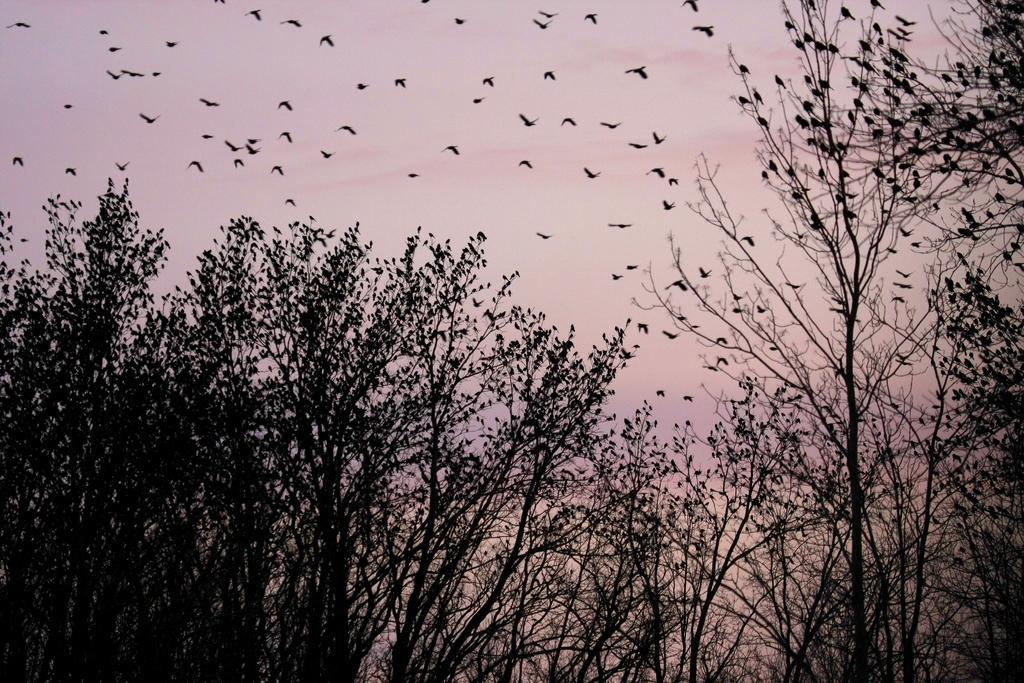How would you summarize this image in a sentence or two? In this picture we can see some birds on the trees and some birds flying in the sky. 